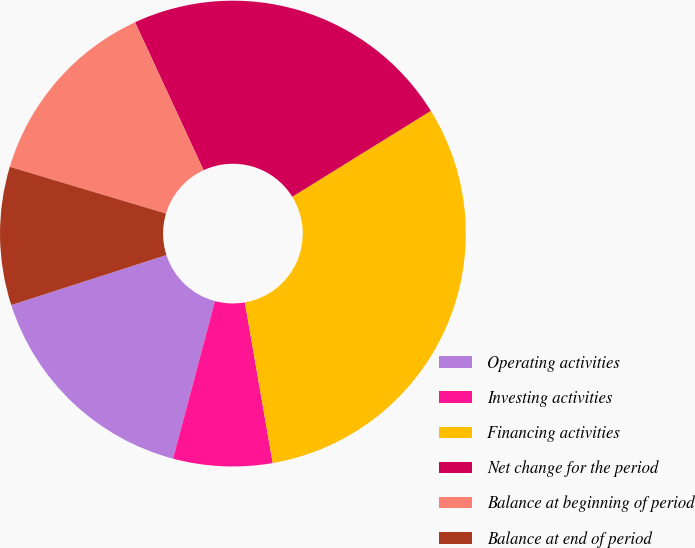Convert chart. <chart><loc_0><loc_0><loc_500><loc_500><pie_chart><fcel>Operating activities<fcel>Investing activities<fcel>Financing activities<fcel>Net change for the period<fcel>Balance at beginning of period<fcel>Balance at end of period<nl><fcel>15.9%<fcel>6.87%<fcel>31.1%<fcel>23.07%<fcel>13.47%<fcel>9.59%<nl></chart> 